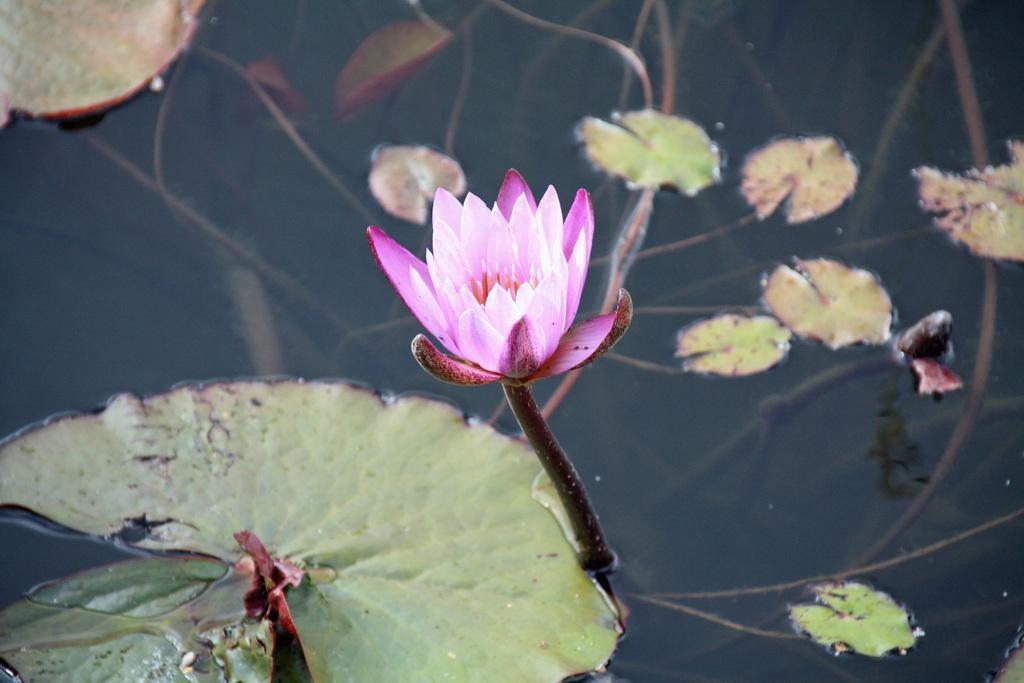Please provide a concise description of this image. In this image at the bottom there is one pond, and in that pond there is one lotus flower and some leaves. 